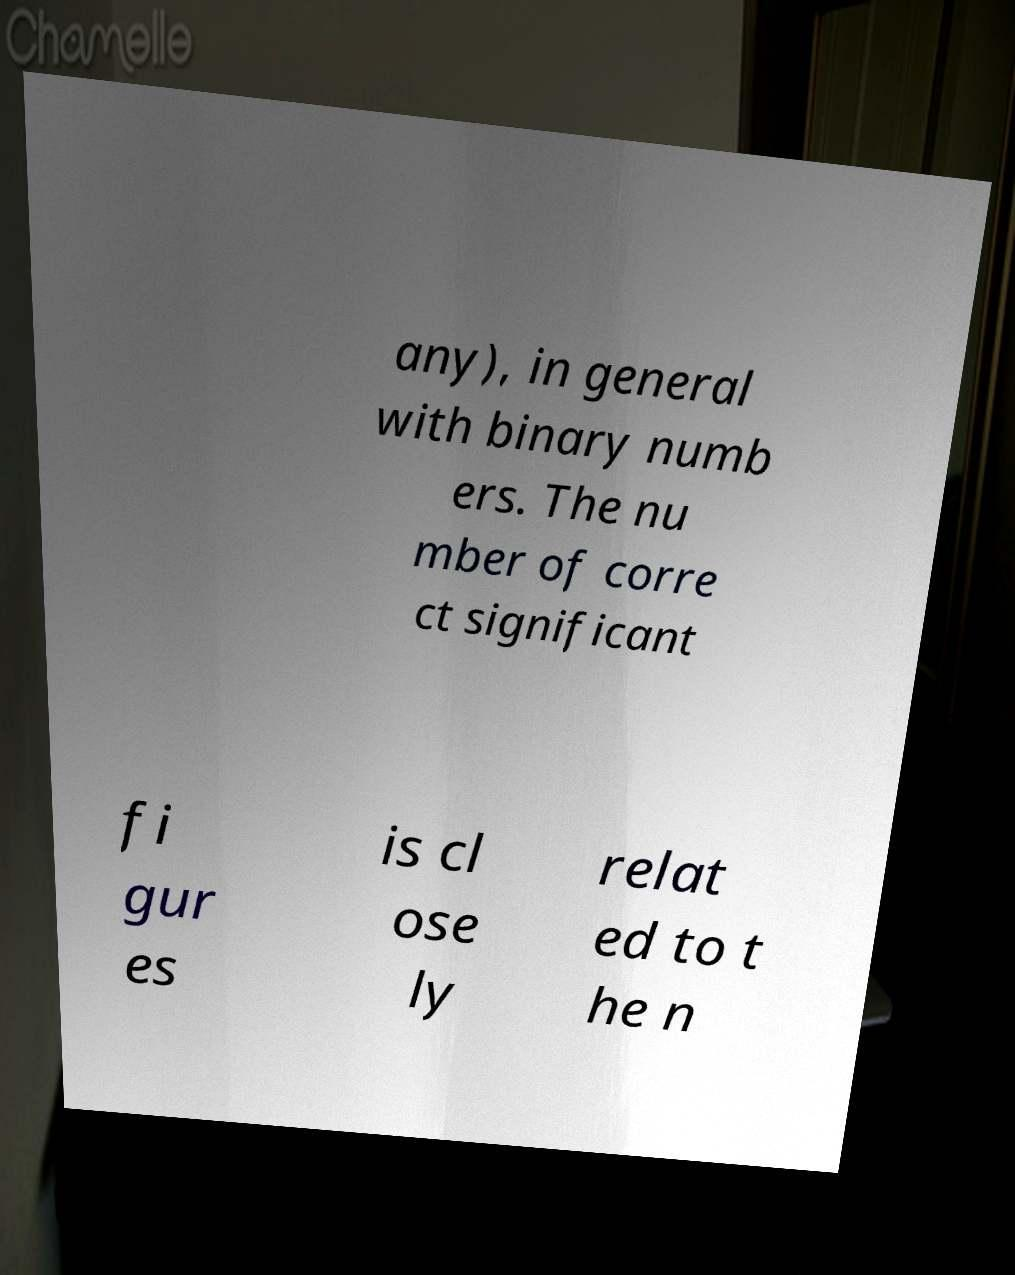Can you accurately transcribe the text from the provided image for me? any), in general with binary numb ers. The nu mber of corre ct significant fi gur es is cl ose ly relat ed to t he n 